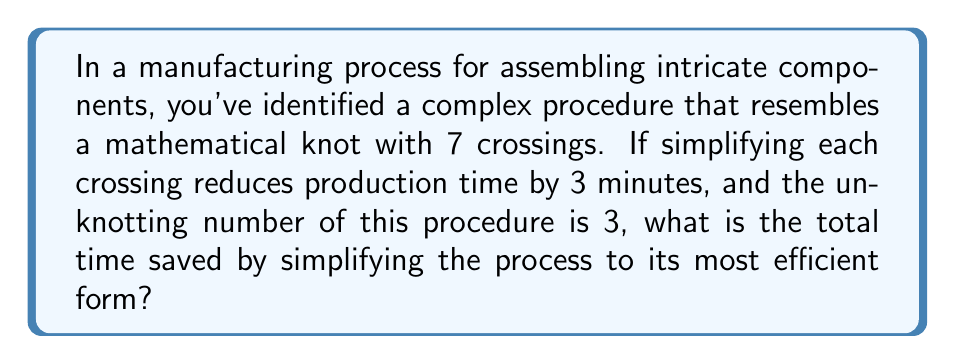Can you answer this question? To solve this problem, we need to understand and apply the concept of the unknotting number in the context of manufacturing procedures. Let's break it down step-by-step:

1. Understand the given information:
   - The complex procedure resembles a knot with 7 crossings.
   - Simplifying each crossing reduces production time by 3 minutes.
   - The unknotting number of this procedure is 3.

2. Recall the definition of unknotting number:
   The unknotting number is the minimum number of crossing changes required to transform a knot into the unknot (the simplest possible knot).

3. Apply the unknotting number to our manufacturing process:
   - We need to make 3 crossing changes to simplify the procedure to its most efficient form.

4. Calculate the time saved:
   - Time saved per crossing change = 3 minutes
   - Total crossing changes needed = 3 (the unknotting number)
   - Total time saved = 3 minutes × 3 changes

5. Perform the final calculation:
   $$ \text{Total time saved} = 3 \text{ minutes} \times 3 = 9 \text{ minutes} $$

Therefore, by simplifying the manufacturing process using the concept of unknotting number, we can save a total of 9 minutes in production time.
Answer: 9 minutes 